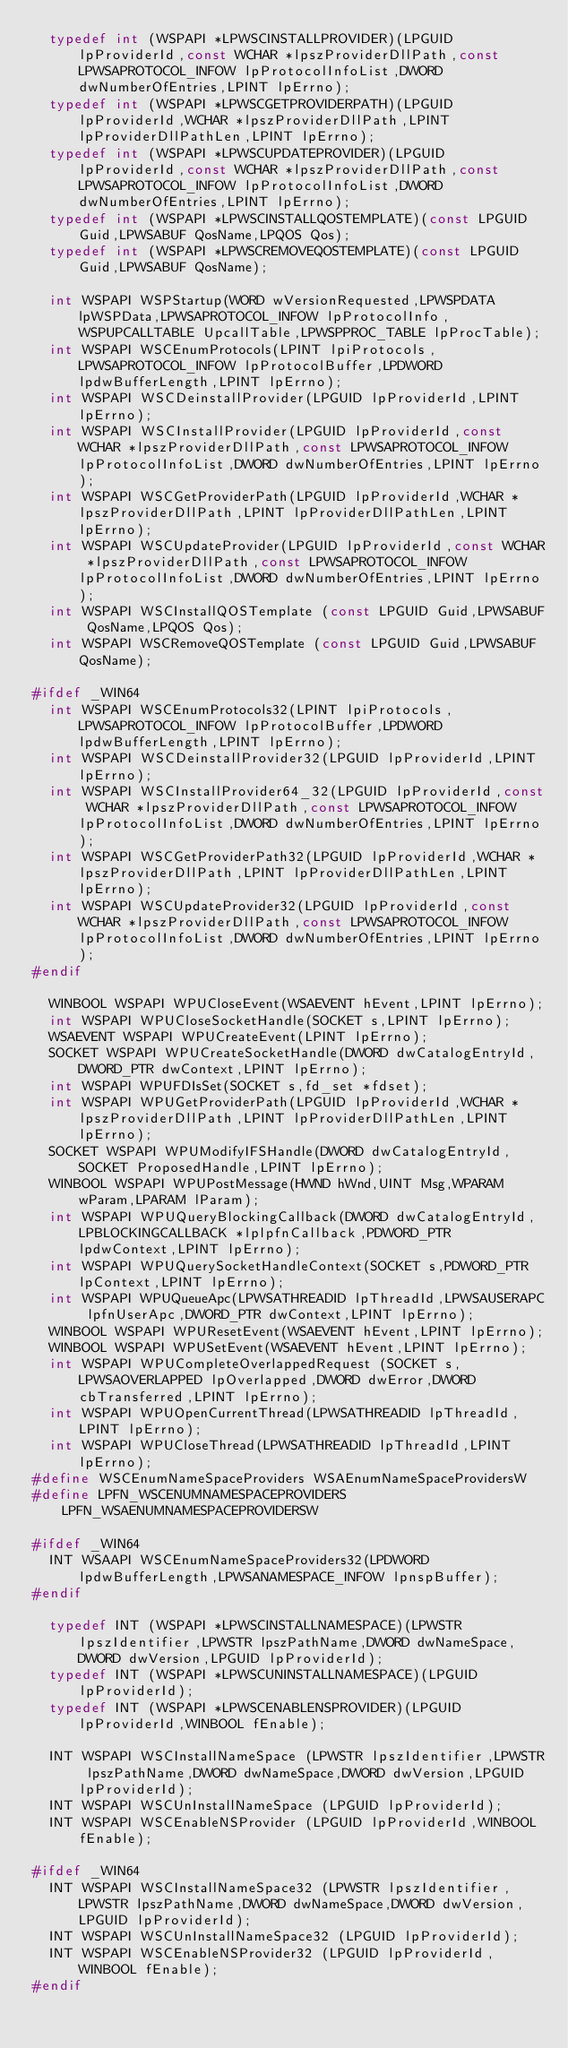Convert code to text. <code><loc_0><loc_0><loc_500><loc_500><_C_>  typedef int (WSPAPI *LPWSCINSTALLPROVIDER)(LPGUID lpProviderId,const WCHAR *lpszProviderDllPath,const LPWSAPROTOCOL_INFOW lpProtocolInfoList,DWORD dwNumberOfEntries,LPINT lpErrno);
  typedef int (WSPAPI *LPWSCGETPROVIDERPATH)(LPGUID lpProviderId,WCHAR *lpszProviderDllPath,LPINT lpProviderDllPathLen,LPINT lpErrno);
  typedef int (WSPAPI *LPWSCUPDATEPROVIDER)(LPGUID lpProviderId,const WCHAR *lpszProviderDllPath,const LPWSAPROTOCOL_INFOW lpProtocolInfoList,DWORD dwNumberOfEntries,LPINT lpErrno);
  typedef int (WSPAPI *LPWSCINSTALLQOSTEMPLATE)(const LPGUID Guid,LPWSABUF QosName,LPQOS Qos);
  typedef int (WSPAPI *LPWSCREMOVEQOSTEMPLATE)(const LPGUID Guid,LPWSABUF QosName);

  int WSPAPI WSPStartup(WORD wVersionRequested,LPWSPDATA lpWSPData,LPWSAPROTOCOL_INFOW lpProtocolInfo,WSPUPCALLTABLE UpcallTable,LPWSPPROC_TABLE lpProcTable);
  int WSPAPI WSCEnumProtocols(LPINT lpiProtocols,LPWSAPROTOCOL_INFOW lpProtocolBuffer,LPDWORD lpdwBufferLength,LPINT lpErrno);
  int WSPAPI WSCDeinstallProvider(LPGUID lpProviderId,LPINT lpErrno);
  int WSPAPI WSCInstallProvider(LPGUID lpProviderId,const WCHAR *lpszProviderDllPath,const LPWSAPROTOCOL_INFOW lpProtocolInfoList,DWORD dwNumberOfEntries,LPINT lpErrno);
  int WSPAPI WSCGetProviderPath(LPGUID lpProviderId,WCHAR *lpszProviderDllPath,LPINT lpProviderDllPathLen,LPINT lpErrno);
  int WSPAPI WSCUpdateProvider(LPGUID lpProviderId,const WCHAR *lpszProviderDllPath,const LPWSAPROTOCOL_INFOW lpProtocolInfoList,DWORD dwNumberOfEntries,LPINT lpErrno);
  int WSPAPI WSCInstallQOSTemplate (const LPGUID Guid,LPWSABUF QosName,LPQOS Qos);
  int WSPAPI WSCRemoveQOSTemplate (const LPGUID Guid,LPWSABUF QosName);

#ifdef _WIN64
  int WSPAPI WSCEnumProtocols32(LPINT lpiProtocols,LPWSAPROTOCOL_INFOW lpProtocolBuffer,LPDWORD lpdwBufferLength,LPINT lpErrno);
  int WSPAPI WSCDeinstallProvider32(LPGUID lpProviderId,LPINT lpErrno);
  int WSPAPI WSCInstallProvider64_32(LPGUID lpProviderId,const WCHAR *lpszProviderDllPath,const LPWSAPROTOCOL_INFOW lpProtocolInfoList,DWORD dwNumberOfEntries,LPINT lpErrno);
  int WSPAPI WSCGetProviderPath32(LPGUID lpProviderId,WCHAR *lpszProviderDllPath,LPINT lpProviderDllPathLen,LPINT lpErrno);
  int WSPAPI WSCUpdateProvider32(LPGUID lpProviderId,const WCHAR *lpszProviderDllPath,const LPWSAPROTOCOL_INFOW lpProtocolInfoList,DWORD dwNumberOfEntries,LPINT lpErrno);
#endif

  WINBOOL WSPAPI WPUCloseEvent(WSAEVENT hEvent,LPINT lpErrno);
  int WSPAPI WPUCloseSocketHandle(SOCKET s,LPINT lpErrno);
  WSAEVENT WSPAPI WPUCreateEvent(LPINT lpErrno);
  SOCKET WSPAPI WPUCreateSocketHandle(DWORD dwCatalogEntryId,DWORD_PTR dwContext,LPINT lpErrno);
  int WSPAPI WPUFDIsSet(SOCKET s,fd_set *fdset);
  int WSPAPI WPUGetProviderPath(LPGUID lpProviderId,WCHAR *lpszProviderDllPath,LPINT lpProviderDllPathLen,LPINT lpErrno);
  SOCKET WSPAPI WPUModifyIFSHandle(DWORD dwCatalogEntryId,SOCKET ProposedHandle,LPINT lpErrno);
  WINBOOL WSPAPI WPUPostMessage(HWND hWnd,UINT Msg,WPARAM wParam,LPARAM lParam);
  int WSPAPI WPUQueryBlockingCallback(DWORD dwCatalogEntryId,LPBLOCKINGCALLBACK *lplpfnCallback,PDWORD_PTR lpdwContext,LPINT lpErrno);
  int WSPAPI WPUQuerySocketHandleContext(SOCKET s,PDWORD_PTR lpContext,LPINT lpErrno);
  int WSPAPI WPUQueueApc(LPWSATHREADID lpThreadId,LPWSAUSERAPC lpfnUserApc,DWORD_PTR dwContext,LPINT lpErrno);
  WINBOOL WSPAPI WPUResetEvent(WSAEVENT hEvent,LPINT lpErrno);
  WINBOOL WSPAPI WPUSetEvent(WSAEVENT hEvent,LPINT lpErrno);
  int WSPAPI WPUCompleteOverlappedRequest (SOCKET s,LPWSAOVERLAPPED lpOverlapped,DWORD dwError,DWORD cbTransferred,LPINT lpErrno);
  int WSPAPI WPUOpenCurrentThread(LPWSATHREADID lpThreadId,LPINT lpErrno);
  int WSPAPI WPUCloseThread(LPWSATHREADID lpThreadId,LPINT lpErrno);
#define WSCEnumNameSpaceProviders WSAEnumNameSpaceProvidersW
#define LPFN_WSCENUMNAMESPACEPROVIDERS LPFN_WSAENUMNAMESPACEPROVIDERSW

#ifdef _WIN64
  INT WSAAPI WSCEnumNameSpaceProviders32(LPDWORD lpdwBufferLength,LPWSANAMESPACE_INFOW lpnspBuffer);
#endif

  typedef INT (WSPAPI *LPWSCINSTALLNAMESPACE)(LPWSTR lpszIdentifier,LPWSTR lpszPathName,DWORD dwNameSpace,DWORD dwVersion,LPGUID lpProviderId);
  typedef INT (WSPAPI *LPWSCUNINSTALLNAMESPACE)(LPGUID lpProviderId);
  typedef INT (WSPAPI *LPWSCENABLENSPROVIDER)(LPGUID lpProviderId,WINBOOL fEnable);

  INT WSPAPI WSCInstallNameSpace (LPWSTR lpszIdentifier,LPWSTR lpszPathName,DWORD dwNameSpace,DWORD dwVersion,LPGUID lpProviderId);
  INT WSPAPI WSCUnInstallNameSpace (LPGUID lpProviderId);
  INT WSPAPI WSCEnableNSProvider (LPGUID lpProviderId,WINBOOL fEnable);

#ifdef _WIN64
  INT WSPAPI WSCInstallNameSpace32 (LPWSTR lpszIdentifier,LPWSTR lpszPathName,DWORD dwNameSpace,DWORD dwVersion,LPGUID lpProviderId);
  INT WSPAPI WSCUnInstallNameSpace32 (LPGUID lpProviderId);
  INT WSPAPI WSCEnableNSProvider32 (LPGUID lpProviderId,WINBOOL fEnable);
#endif
</code> 